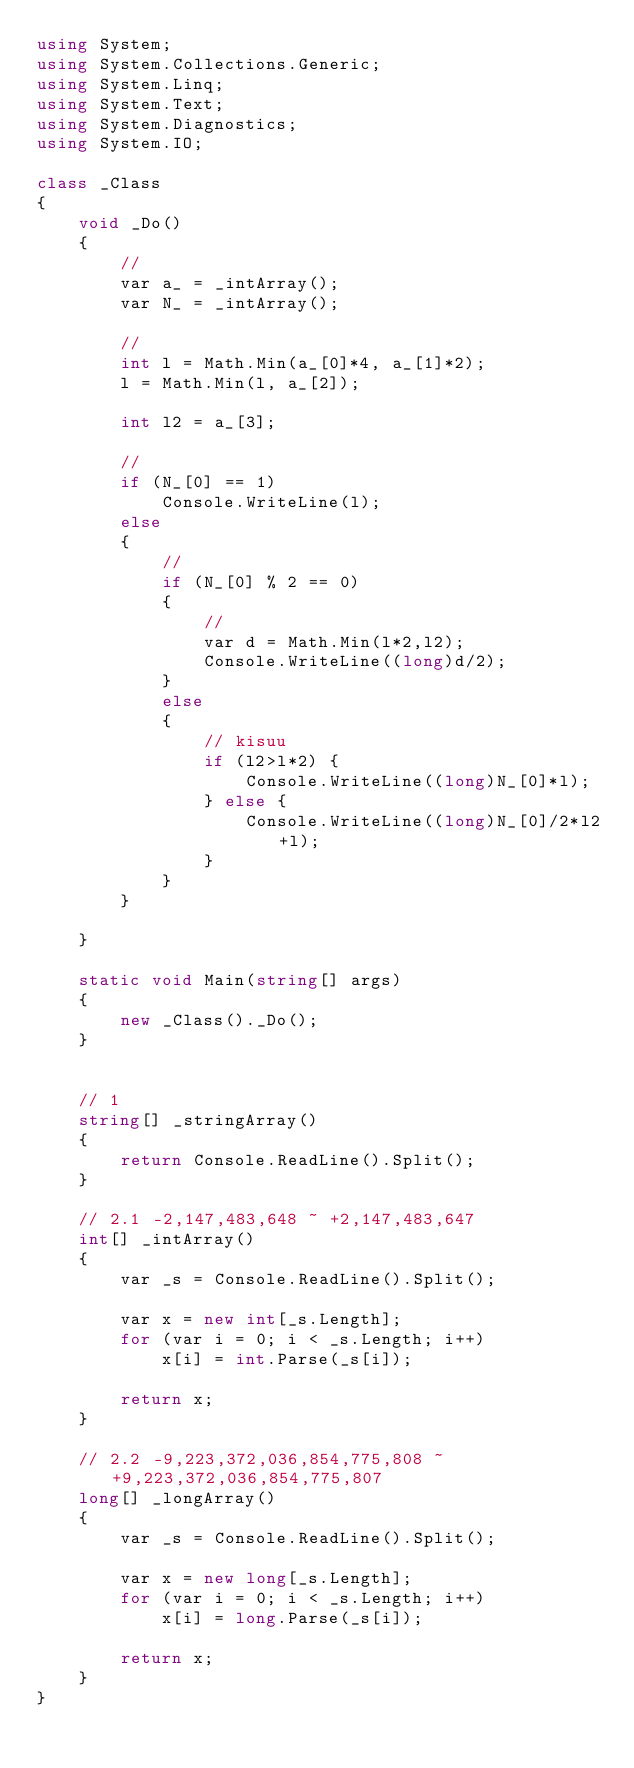<code> <loc_0><loc_0><loc_500><loc_500><_C#_>using System;
using System.Collections.Generic;
using System.Linq;
using System.Text;
using System.Diagnostics;
using System.IO;

class _Class
{
	void _Do()
	{
		//
		var a_ = _intArray();
		var N_ = _intArray();
		
		//
		int l = Math.Min(a_[0]*4, a_[1]*2);
		l = Math.Min(l, a_[2]);

		int l2 = a_[3];

		//
		if (N_[0] == 1)
			Console.WriteLine(l);
		else
		{
			//
			if (N_[0] % 2 == 0)
			{
				//
				var d = Math.Min(l*2,l2);
				Console.WriteLine((long)d/2);
			}
			else
			{
				// kisuu
				if (l2>l*2) {
					Console.WriteLine((long)N_[0]*l);
				} else {
					Console.WriteLine((long)N_[0]/2*l2+l);
				}
			}
		}

	}	

	static void Main(string[] args)
	{
		new _Class()._Do();
	}


	// 1
	string[] _stringArray()
	{
		return Console.ReadLine().Split();
	}

	// 2.1 -2,147,483,648 ~ +2,147,483,647
	int[] _intArray()
	{
		var _s = Console.ReadLine().Split();

		var x = new int[_s.Length];
		for (var i = 0; i < _s.Length; i++)
			x[i] = int.Parse(_s[i]);

		return x;
	}

	// 2.2 -9,223,372,036,854,775,808 ~ +9,223,372,036,854,775,807
	long[] _longArray()
	{
		var _s = Console.ReadLine().Split();

		var x = new long[_s.Length];
		for (var i = 0; i < _s.Length; i++)
			x[i] = long.Parse(_s[i]);

		return x;
	}
}

</code> 